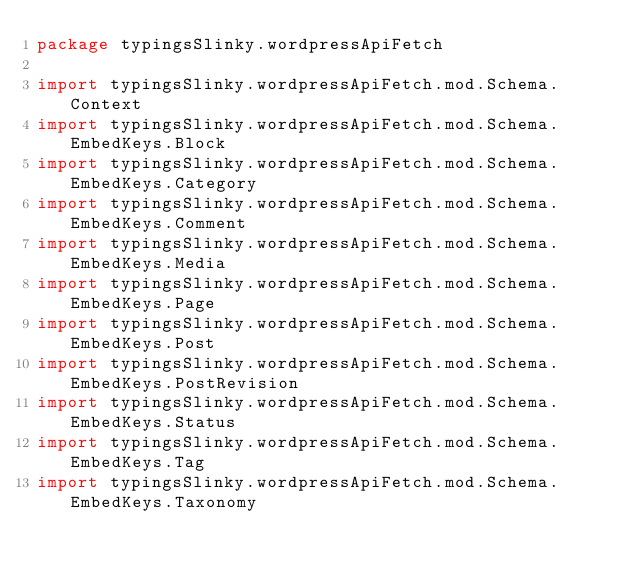Convert code to text. <code><loc_0><loc_0><loc_500><loc_500><_Scala_>package typingsSlinky.wordpressApiFetch

import typingsSlinky.wordpressApiFetch.mod.Schema.Context
import typingsSlinky.wordpressApiFetch.mod.Schema.EmbedKeys.Block
import typingsSlinky.wordpressApiFetch.mod.Schema.EmbedKeys.Category
import typingsSlinky.wordpressApiFetch.mod.Schema.EmbedKeys.Comment
import typingsSlinky.wordpressApiFetch.mod.Schema.EmbedKeys.Media
import typingsSlinky.wordpressApiFetch.mod.Schema.EmbedKeys.Page
import typingsSlinky.wordpressApiFetch.mod.Schema.EmbedKeys.Post
import typingsSlinky.wordpressApiFetch.mod.Schema.EmbedKeys.PostRevision
import typingsSlinky.wordpressApiFetch.mod.Schema.EmbedKeys.Status
import typingsSlinky.wordpressApiFetch.mod.Schema.EmbedKeys.Tag
import typingsSlinky.wordpressApiFetch.mod.Schema.EmbedKeys.Taxonomy</code> 